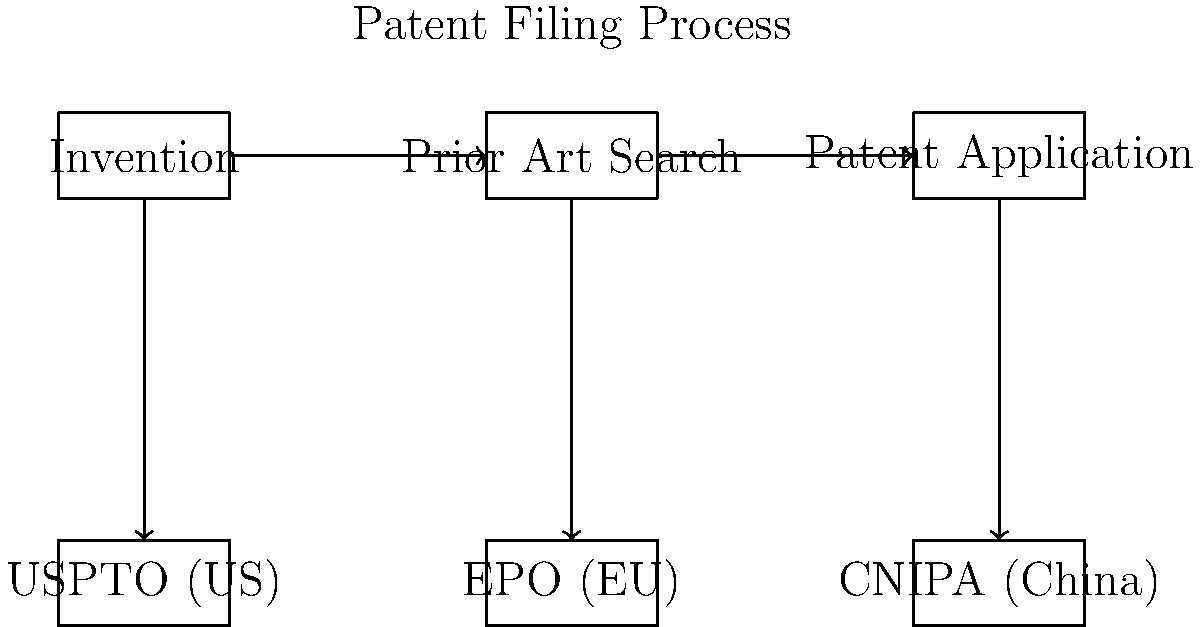In the patent filing process illustrated above, which step directly precedes the submission of a patent application to various patent offices such as USPTO, EPO, and CNIPA? To answer this question, let's analyze the diagram step-by-step:

1. The diagram shows a three-step process at the top:
   a) Invention
   b) Prior Art Search
   c) Patent Application

2. These steps are connected by arrows, indicating the flow of the process from left to right.

3. Below these steps, we see three patent offices:
   a) USPTO (United States Patent and Trademark Office)
   b) EPO (European Patent Office)
   c) CNIPA (China National Intellectual Property Administration)

4. Vertical arrows connect the "Patent Application" step to each of these patent offices.

5. The question asks about the step that directly precedes the submission of a patent application to various patent offices.

6. Looking at the diagram, we can see that the "Patent Application" step is directly connected to the patent offices.

7. The step immediately before "Patent Application" is "Prior Art Search".

Therefore, the step that directly precedes the submission of a patent application to various patent offices is the Prior Art Search.
Answer: Prior Art Search 